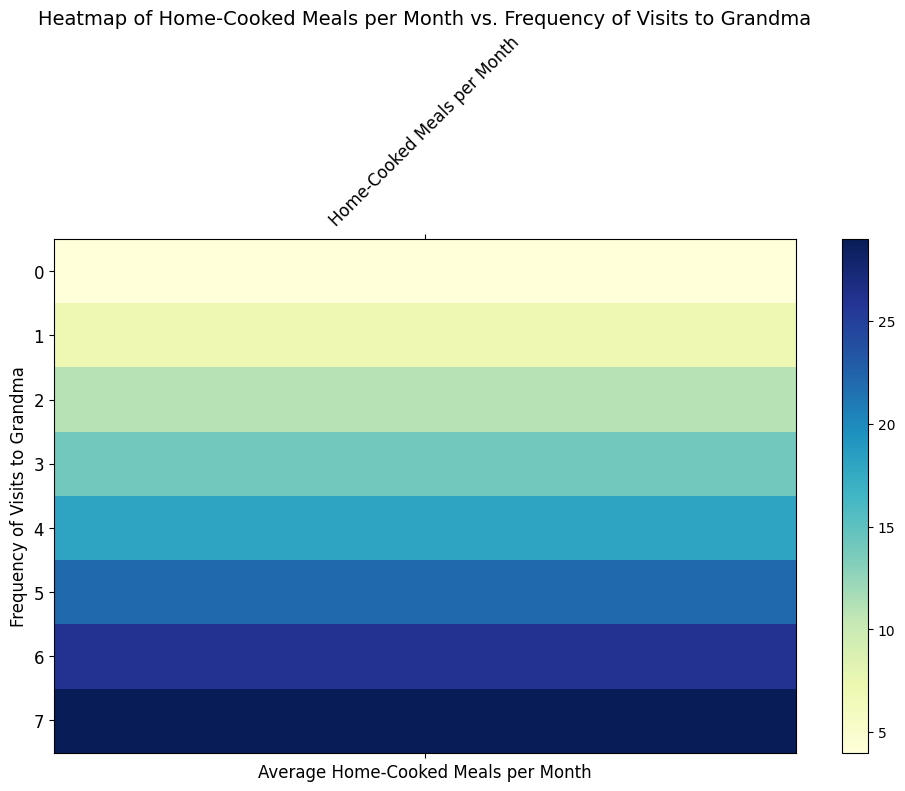What's the general trend in Home-Cooked Meals per Month as the Frequency of Visits to Grandma increases? As the frequency of visits to grandma increases from 0 to 7, the average number of home-cooked meals per month generally increases. This is indicated by the color gradient change from lighter shades for fewer visits to darker shades for more visits.
Answer: Increases Which frequency of visits to grandma corresponds to the highest average number of home-cooked meals per month? Look for the darkest shade in the heatmap, which represents the highest number of home-cooked meals per month. The darkest shade is at the frequency of 7 visits per month, indicating the highest average.
Answer: 7 How does the average number of home-cooked meals change between visiting grandma 2 times per month and 3 times per month? Spot the colors corresponding to 2 and 3 visits on the heatmap and compare their intensities. The color intensity increases slightly from 2 visits (around 11-12 meals) to 3 visits (around 13-15 meals).
Answer: Increases What is the approximate average number of home-cooked meals per month for single parents who visit grandma 4 times a month? Identify the color shade for the frequency of 4 visits. The corresponding shade indicates an approximate range of 17-19 home-cooked meals per month.
Answer: 17-19 If the trend continues, what would you expect the average number of home-cooked meals to be for single parents who could visit grandma 8 times a month? Assuming the increasing trend continues, an extrapolation from the pattern suggests a further increase beyond the 7 visits frequency (which averages around 29-30). The average might be slightly higher, possibly around 31-32 meals.
Answer: 31-32 